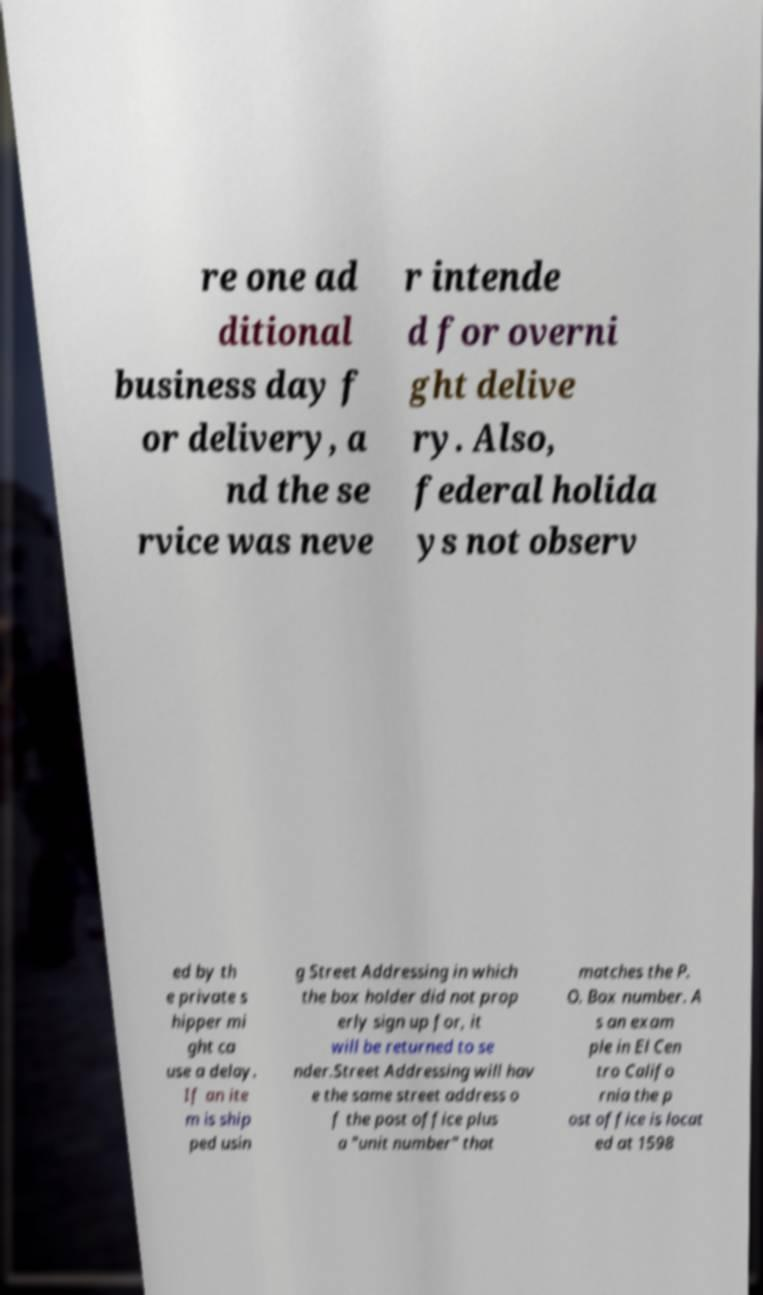Can you read and provide the text displayed in the image?This photo seems to have some interesting text. Can you extract and type it out for me? re one ad ditional business day f or delivery, a nd the se rvice was neve r intende d for overni ght delive ry. Also, federal holida ys not observ ed by th e private s hipper mi ght ca use a delay. If an ite m is ship ped usin g Street Addressing in which the box holder did not prop erly sign up for, it will be returned to se nder.Street Addressing will hav e the same street address o f the post office plus a "unit number" that matches the P. O. Box number. A s an exam ple in El Cen tro Califo rnia the p ost office is locat ed at 1598 